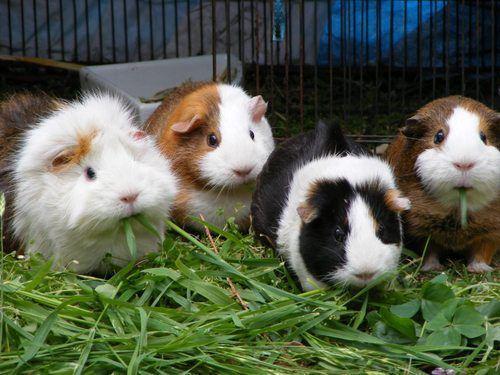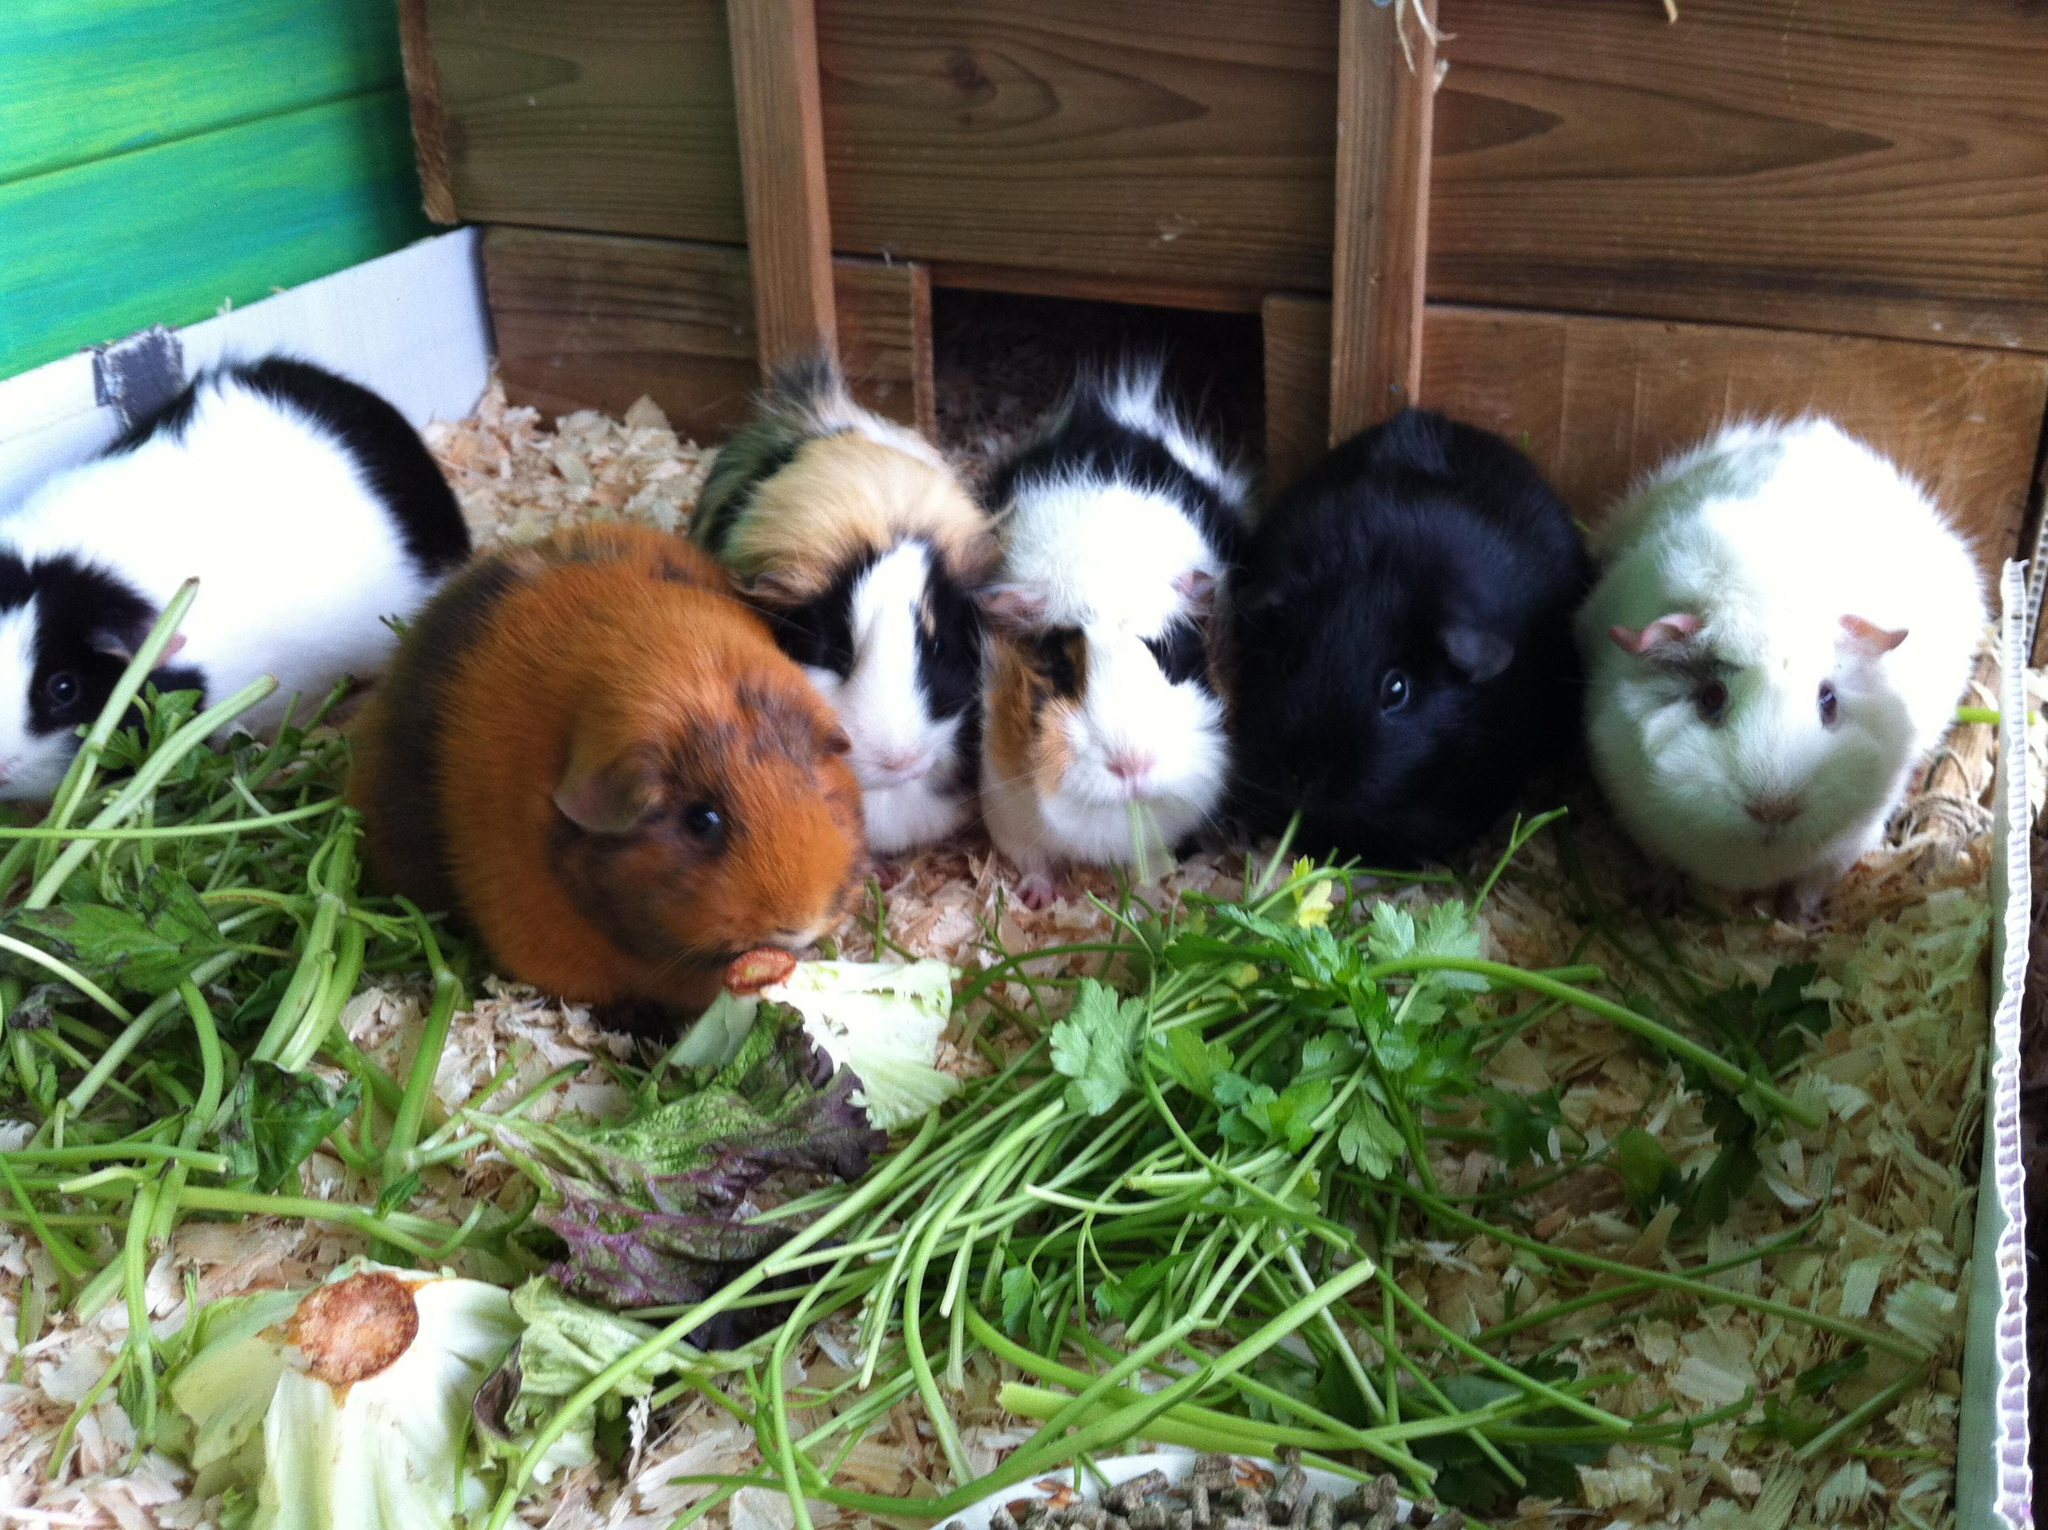The first image is the image on the left, the second image is the image on the right. Analyze the images presented: Is the assertion "At least one of the images is of a single guinea pig laying in the grass." valid? Answer yes or no. No. 